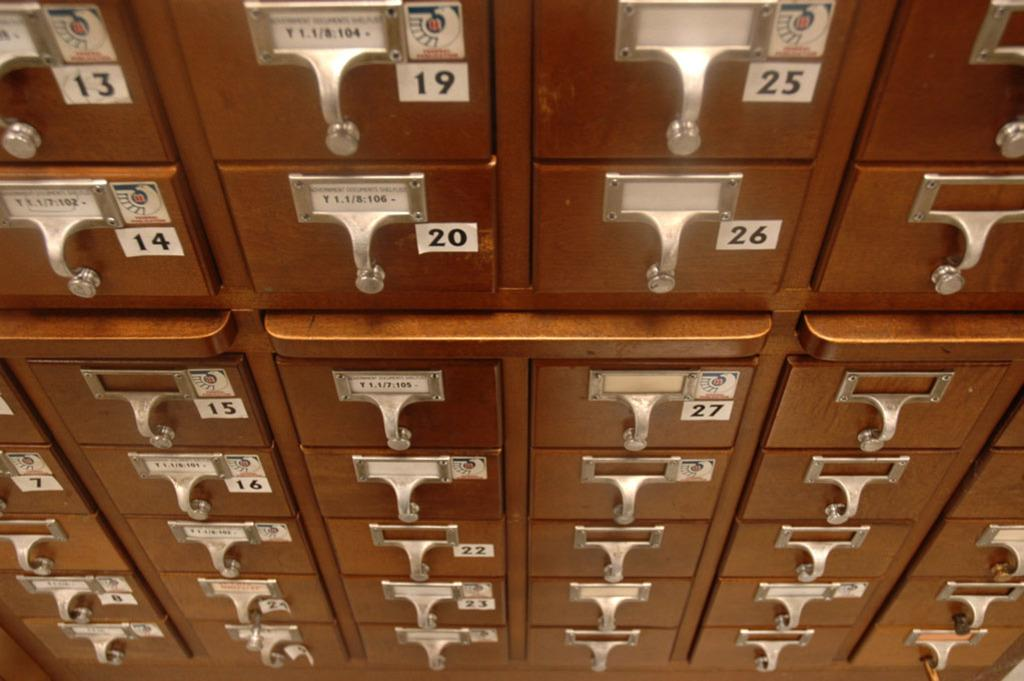What type of storage units are present in the image? There are locker boxes in the image. How can the locker boxes be identified or distinguished from one another? There are number tags on the locker boxes. What type of clouds can be seen in the image? There are no clouds present in the image; it only features locker boxes with number tags. 